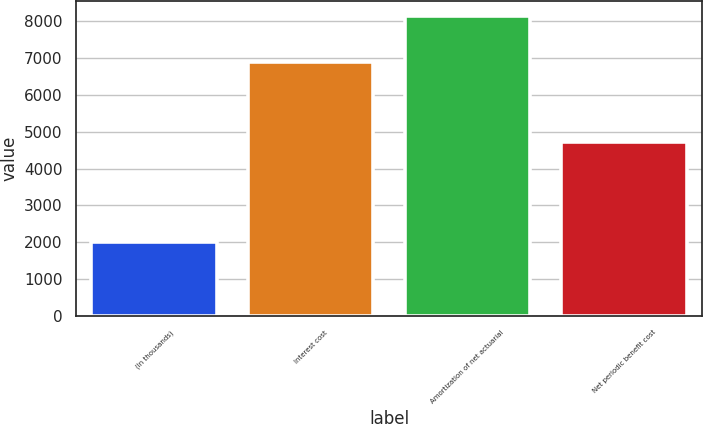<chart> <loc_0><loc_0><loc_500><loc_500><bar_chart><fcel>(In thousands)<fcel>Interest cost<fcel>Amortization of net actuarial<fcel>Net periodic benefit cost<nl><fcel>2013<fcel>6885<fcel>8132<fcel>4722<nl></chart> 